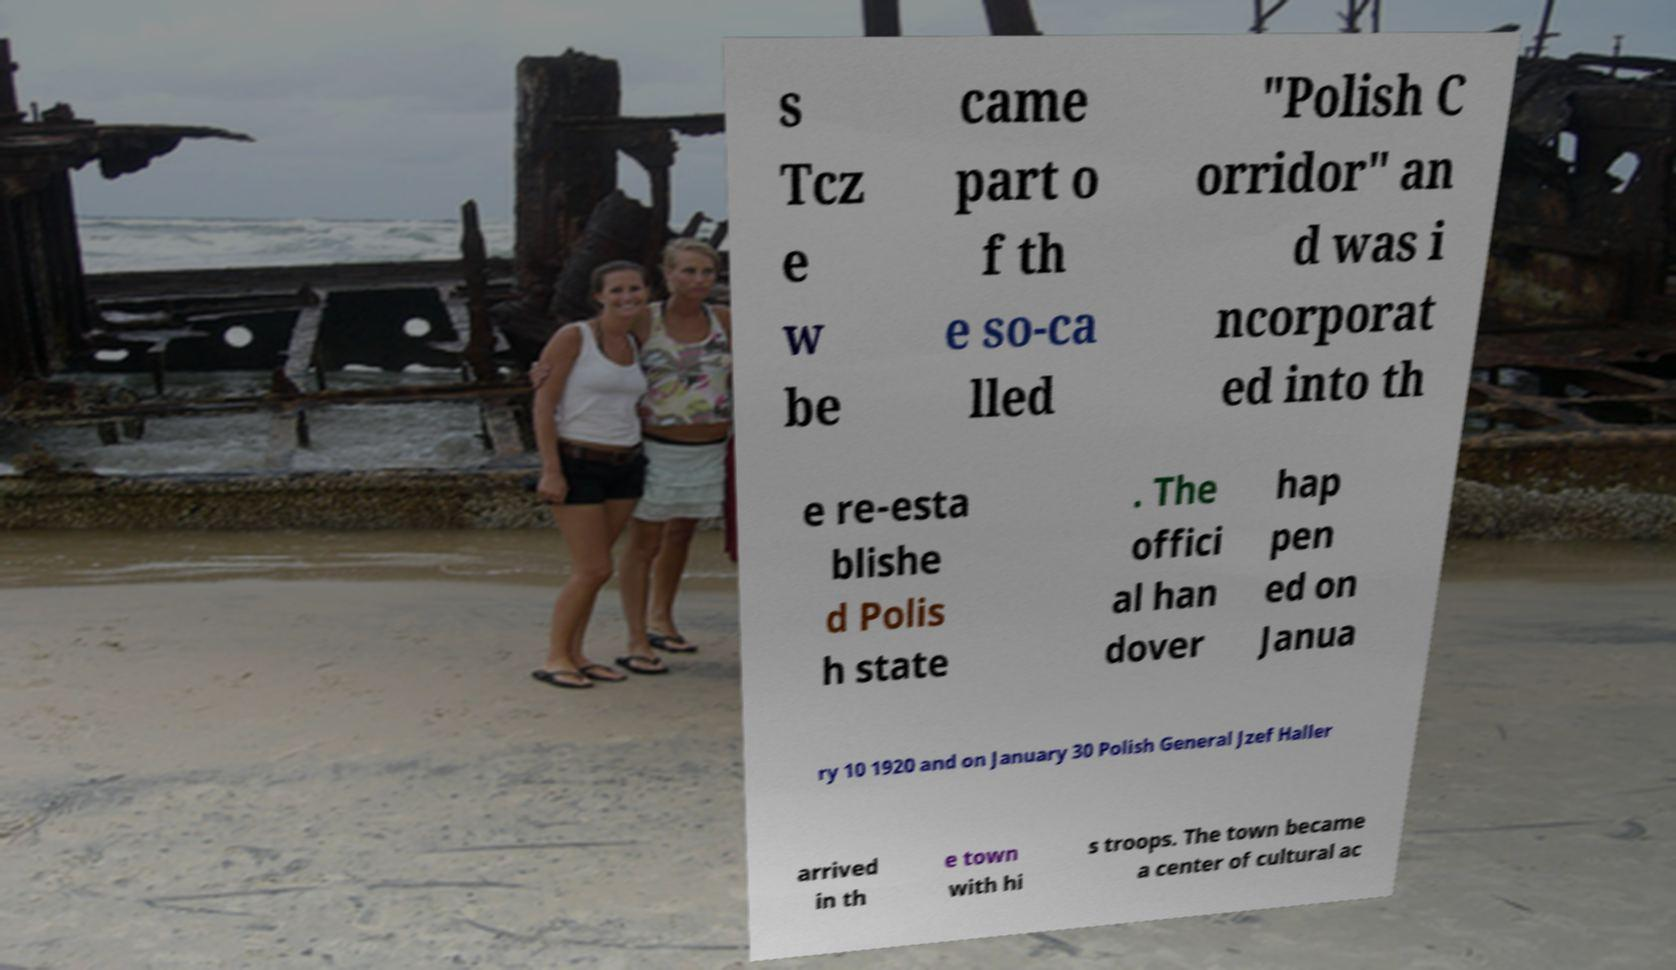Could you assist in decoding the text presented in this image and type it out clearly? s Tcz e w be came part o f th e so-ca lled "Polish C orridor" an d was i ncorporat ed into th e re-esta blishe d Polis h state . The offici al han dover hap pen ed on Janua ry 10 1920 and on January 30 Polish General Jzef Haller arrived in th e town with hi s troops. The town became a center of cultural ac 